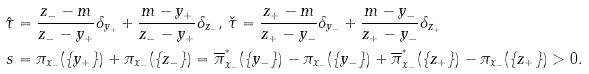Convert formula to latex. <formula><loc_0><loc_0><loc_500><loc_500>\hat { \tau } & = \frac { z _ { - } - m } { z _ { - } - y _ { + } } \delta _ { y _ { + } } + \frac { m - y _ { + } } { z _ { - } - y _ { + } } \delta _ { z _ { - } } , \, \check { \tau } = \frac { z _ { + } - m } { z _ { + } - y _ { - } } \delta _ { y _ { - } } + \frac { m - y _ { - } } { z _ { + } - y _ { - } } \delta _ { z _ { + } } \\ s & = \pi _ { x _ { - } } ( \{ y _ { + } \} ) + \pi _ { x _ { - } } ( \{ z _ { - } \} ) = \overline { \pi } _ { x _ { - } } ^ { ^ { * } } ( \{ y _ { - } \} ) - \pi _ { x _ { - } } ( \{ y _ { - } \} ) + \overline { \pi } _ { x _ { - } } ^ { ^ { * } } ( \{ z _ { + } \} ) - \pi _ { x _ { - } } ( \{ z _ { + } \} ) > 0 .</formula> 